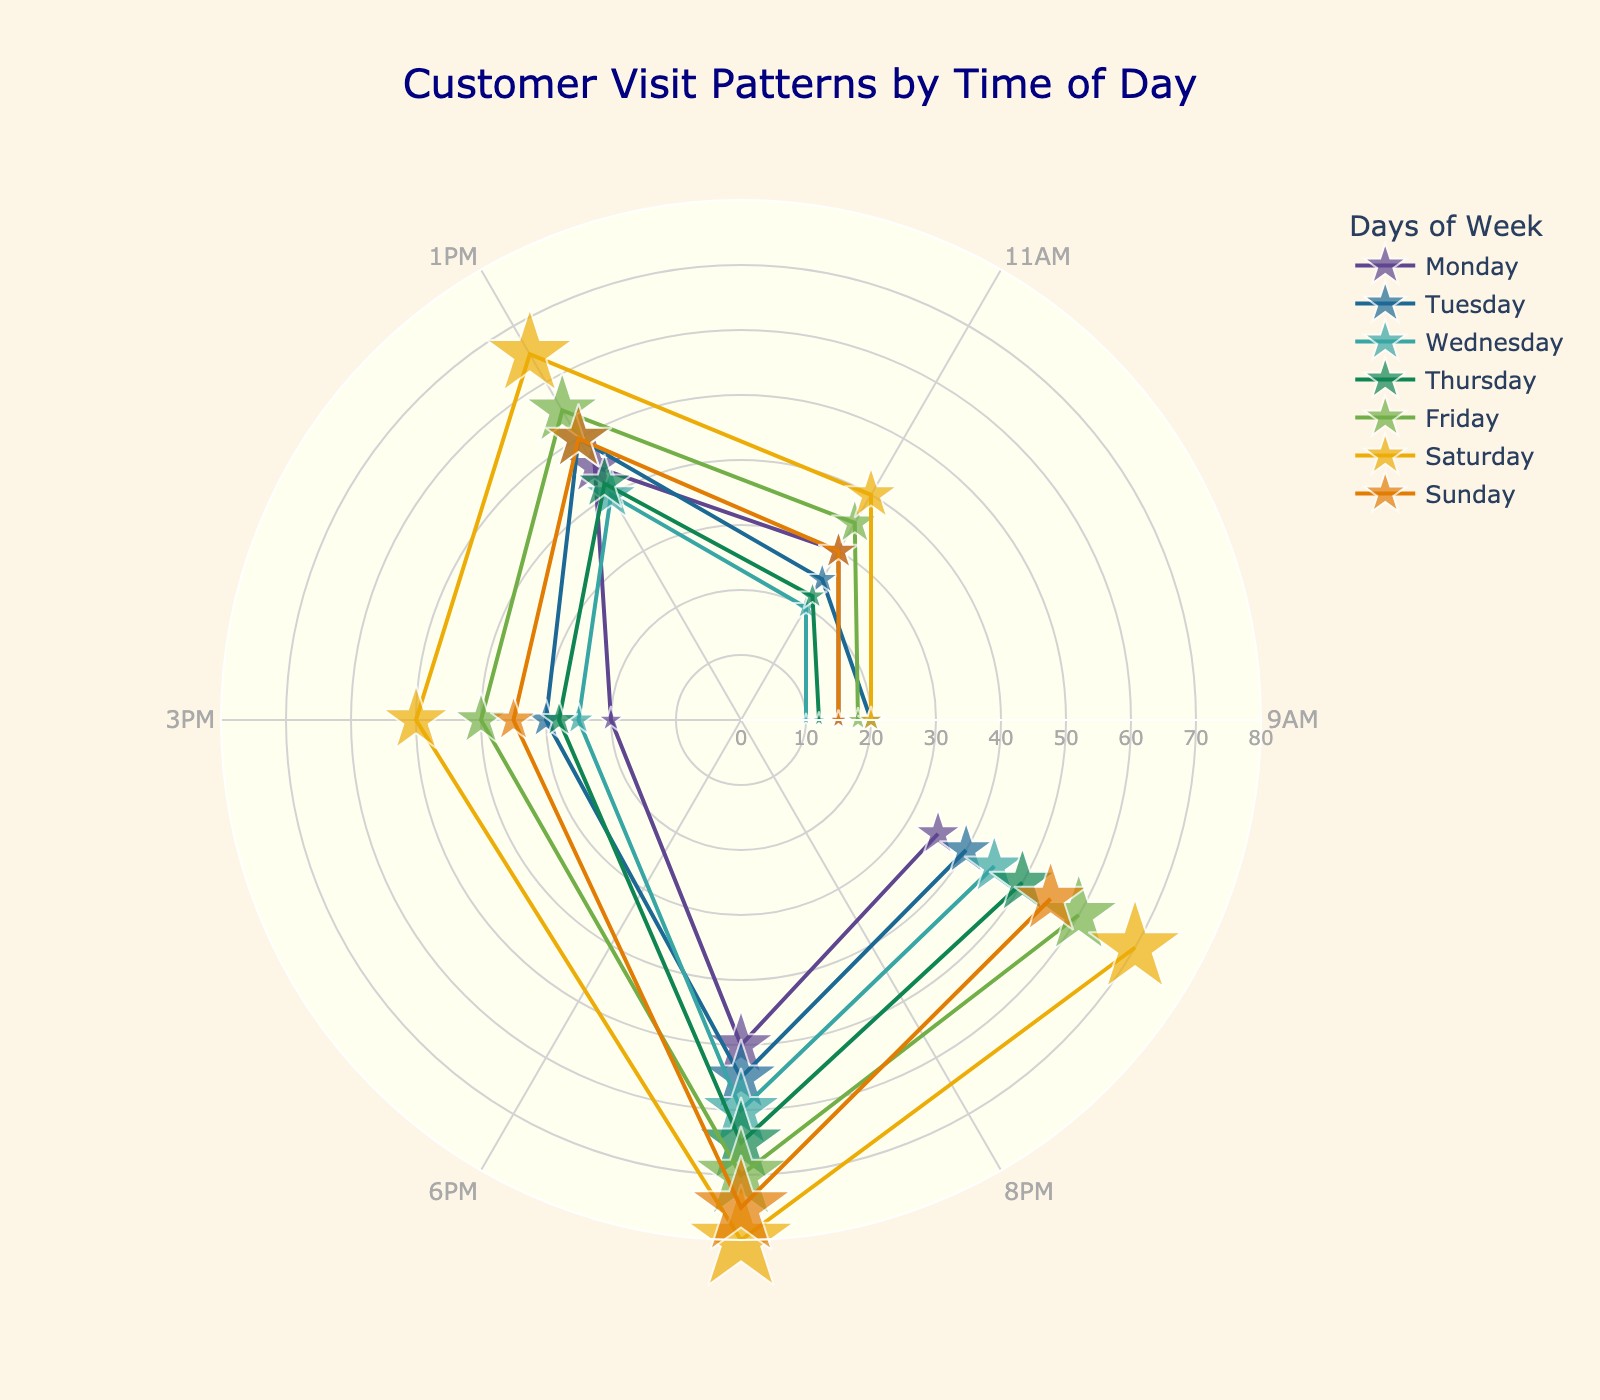What is the title of the chart? The title is usually positioned at the top of the chart. In the given chart, it is indicated as "Customer Visit Patterns by Time of Day".
Answer: Customer Visit Patterns by Time of Day Which day has the highest number of visitors in the evening at 6 PM? To determine this, look at the radial distance for each day's marker at the angle that represents 6 PM (240 degrees). The longest radial distance for that time is on Saturday with 80 visitors.
Answer: Saturday On which day are customer visits at 3 PM the lowest? Examine the markers placed at the 180-degree position (3 PM) for each day. The smallest radial distance (indicating the fewest visitors) occurs on Monday with 20 visitors.
Answer: Monday How does the pattern of customer visits on Tuesdays compare to Fridays at 1 PM? Compare the markers at the 120-degree angle (1 PM) for Tuesday and Friday. Tuesday has 50 visitors while Friday has 55 visitors, showing that Friday has more visitors at that time.
Answer: Friday What is the overall trend in visitor count from 9 AM to 8 PM on Sundays? To observe the trend, follow the markers for Sunday at increasing angles from 0 to 300 degrees. The visitor count starts at 15 at 9 AM, increases to peak at 75 at 6 PM, and then slightly descends to 55 at 8 PM.
Answer: Increasing then slight decrease Across all days, what is the median number of visitors at 11 AM? Calculate the visitor counts at 11 AM for all days: 30, 25, 20, 22, 35, 40, 30. Sort these values: 20, 22, 25, 30, 30, 35, 40. The median value, the fourth value in this sorted list, is 30.
Answer: 30 Which two days have the most similar visitor patterns by radial distance? By visually comparing the connected lines (representing each day), Tuesday and Sunday both exhibit increasing trends peaking around evening times with close maxima values (55 on Tuesday and 75 on Sunday), indicating similar patterns.
Answer: Tuesday and Sunday How many more visitors are there on Saturdays at 8 PM compared to Wednesdays at the same time? Find the number of visitors on Saturday at 8 PM (300 degrees), which is 70, and on Wednesday at 8 PM, which is 45. The difference is 70 - 45 = 25.
Answer: 25 What time of day tends to have the highest customer visits consistently across the week? Observing the radials, the pattern peaks frequently around 6 PM (240 degrees) on most days, indicating this as the time with the highest customer visits.
Answer: 6 PM 